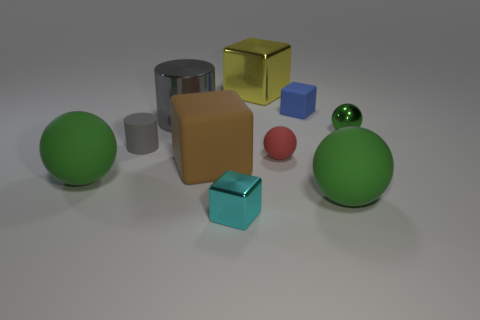There is a tiny shiny object that is in front of the red matte object; does it have the same color as the matte sphere behind the large rubber cube? no 